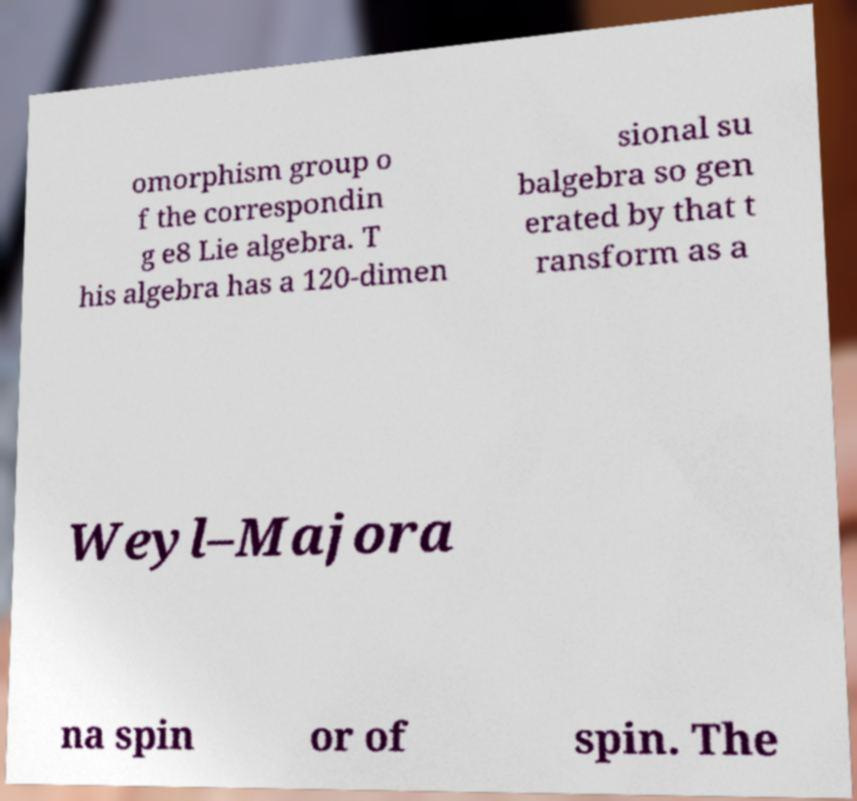Please identify and transcribe the text found in this image. omorphism group o f the correspondin g e8 Lie algebra. T his algebra has a 120-dimen sional su balgebra so gen erated by that t ransform as a Weyl–Majora na spin or of spin. The 